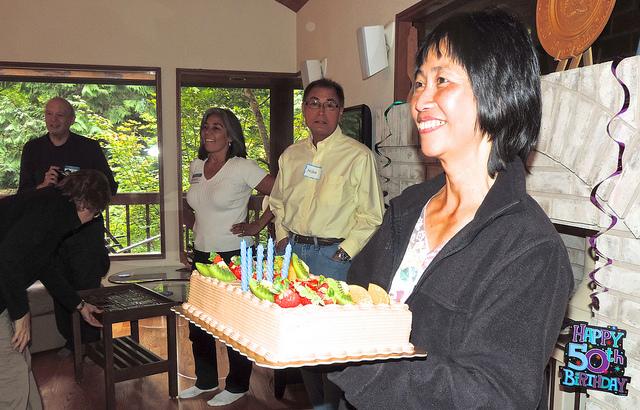How many people are there here?
Concise answer only. 5. How many candles are on that cake?
Concise answer only. 5. Are these people at an indoor function?
Short answer required. Yes. What shape is the birthday cake?
Keep it brief. Rectangle. What color hair does the woman holding the cake have?
Give a very brief answer. Black. 